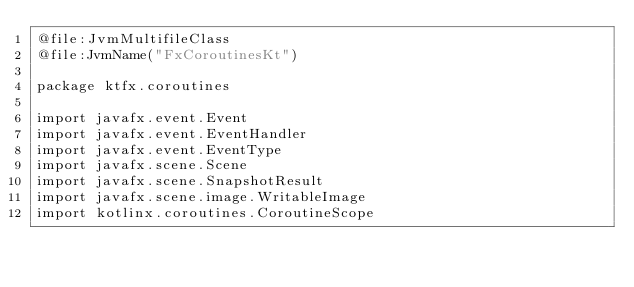<code> <loc_0><loc_0><loc_500><loc_500><_Kotlin_>@file:JvmMultifileClass
@file:JvmName("FxCoroutinesKt")

package ktfx.coroutines

import javafx.event.Event
import javafx.event.EventHandler
import javafx.event.EventType
import javafx.scene.Scene
import javafx.scene.SnapshotResult
import javafx.scene.image.WritableImage
import kotlinx.coroutines.CoroutineScope</code> 